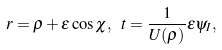Convert formula to latex. <formula><loc_0><loc_0><loc_500><loc_500>r = \rho + \epsilon \cos \chi , \ t = \frac { 1 } { U ( \rho ) } \epsilon \psi _ { I } ,</formula> 